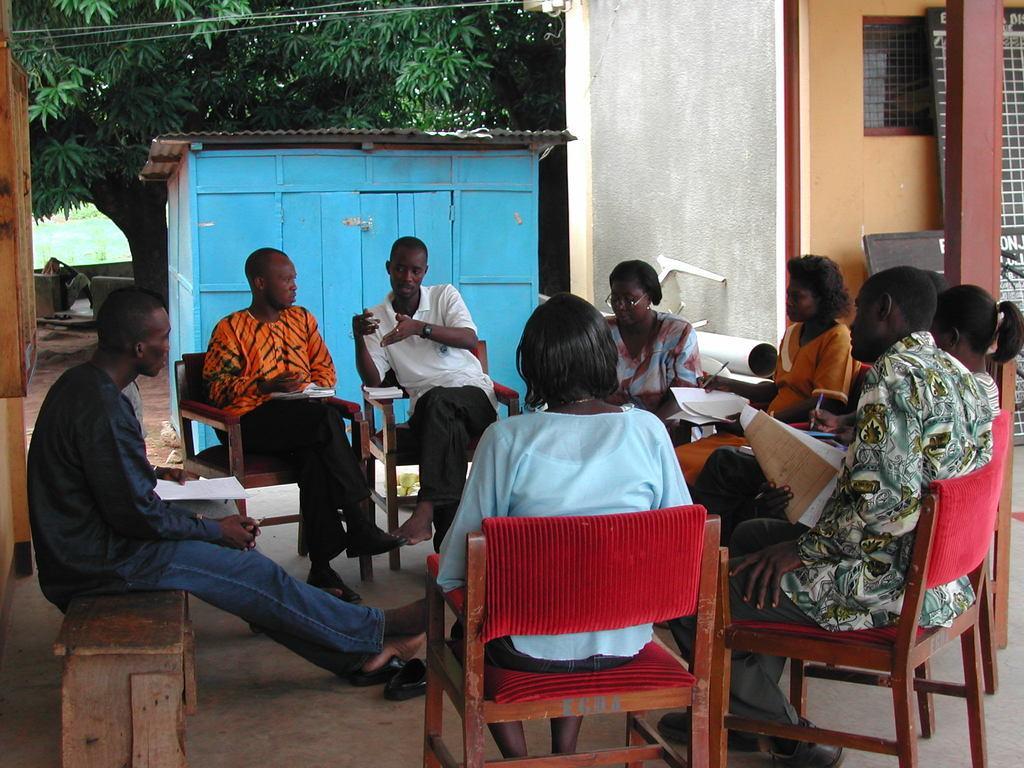In one or two sentences, can you explain what this image depicts? In this image i could see couple of persons sitting around on the chairs, red colored chairs. The woman front of the image wearing light blue shirt and a black short and men beside her is sitting holding papers in his hand. The other person in the white shirt is expressing something. In the background i could see a big tree and in between the person and the tree there is a small room blue in color and there is white colored wall in the right side of the picture and in the left there is some wooden cabinets. The person dressed in black shirt and blue jeans is sitting on the bench. 